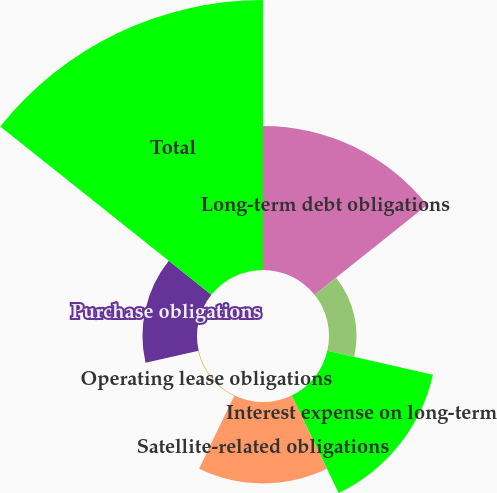Convert chart. <chart><loc_0><loc_0><loc_500><loc_500><pie_chart><fcel>Long-term debt obligations<fcel>Capital lease obligations<fcel>Interest expense on long-term<fcel>Satellite-related obligations<fcel>Operating lease obligations<fcel>Purchase obligations<fcel>Total<nl><fcel>20.98%<fcel>4.01%<fcel>15.79%<fcel>11.86%<fcel>0.09%<fcel>7.94%<fcel>39.34%<nl></chart> 